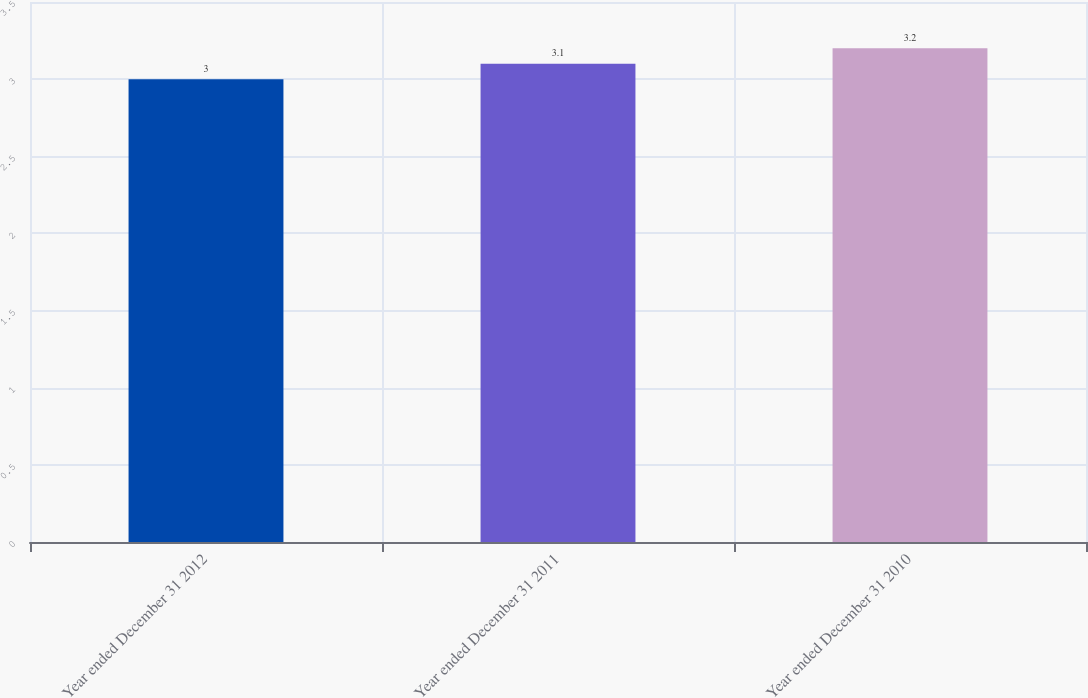<chart> <loc_0><loc_0><loc_500><loc_500><bar_chart><fcel>Year ended December 31 2012<fcel>Year ended December 31 2011<fcel>Year ended December 31 2010<nl><fcel>3<fcel>3.1<fcel>3.2<nl></chart> 